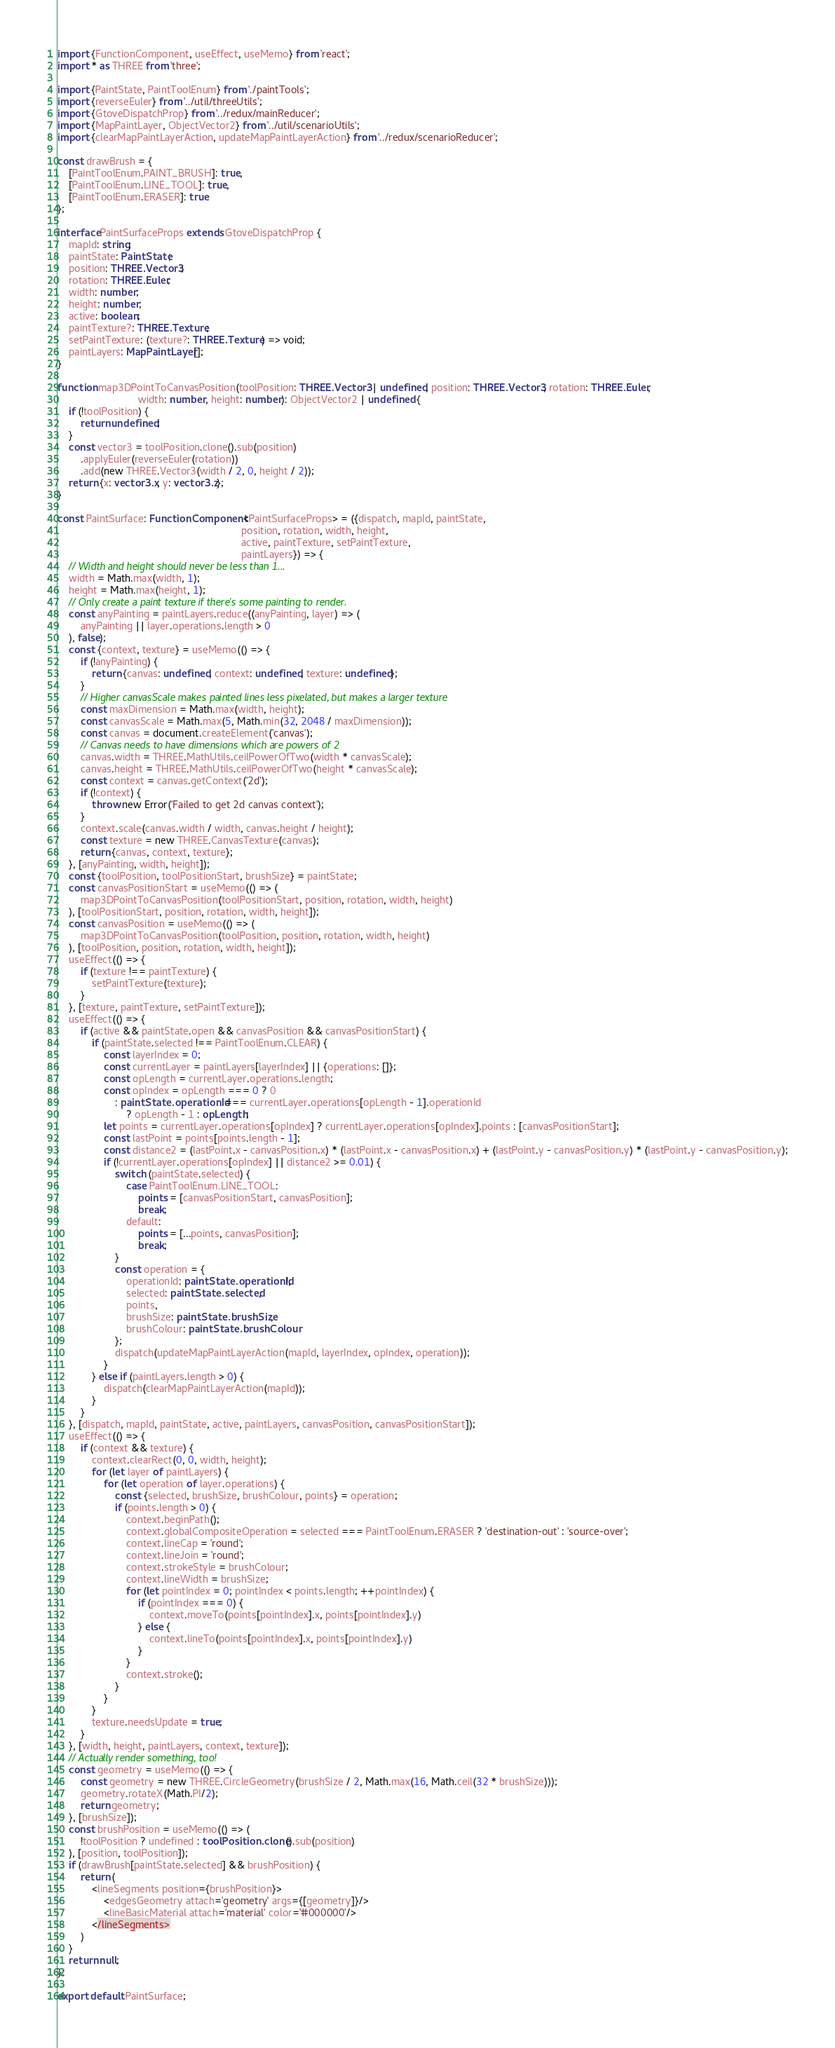Convert code to text. <code><loc_0><loc_0><loc_500><loc_500><_TypeScript_>import {FunctionComponent, useEffect, useMemo} from 'react';
import * as THREE from 'three';

import {PaintState, PaintToolEnum} from './paintTools';
import {reverseEuler} from '../util/threeUtils';
import {GtoveDispatchProp} from '../redux/mainReducer';
import {MapPaintLayer, ObjectVector2} from '../util/scenarioUtils';
import {clearMapPaintLayerAction, updateMapPaintLayerAction} from '../redux/scenarioReducer';

const drawBrush = {
    [PaintToolEnum.PAINT_BRUSH]: true,
    [PaintToolEnum.LINE_TOOL]: true,
    [PaintToolEnum.ERASER]: true
};

interface PaintSurfaceProps extends GtoveDispatchProp {
    mapId: string;
    paintState: PaintState;
    position: THREE.Vector3;
    rotation: THREE.Euler;
    width: number;
    height: number;
    active: boolean;
    paintTexture?: THREE.Texture;
    setPaintTexture: (texture?: THREE.Texture) => void;
    paintLayers: MapPaintLayer[];
}

function map3DPointToCanvasPosition(toolPosition: THREE.Vector3 | undefined, position: THREE.Vector3, rotation: THREE.Euler,
                            width: number, height: number): ObjectVector2 | undefined {
    if (!toolPosition) {
        return undefined;
    }
    const vector3 = toolPosition.clone().sub(position)
        .applyEuler(reverseEuler(rotation))
        .add(new THREE.Vector3(width / 2, 0, height / 2));
    return {x: vector3.x, y: vector3.z};
}

const PaintSurface: FunctionComponent<PaintSurfaceProps> = ({dispatch, mapId, paintState,
                                                                position, rotation, width, height,
                                                                active, paintTexture, setPaintTexture,
                                                                paintLayers}) => {
    // Width and height should never be less than 1...
    width = Math.max(width, 1);
    height = Math.max(height, 1);
    // Only create a paint texture if there's some painting to render.
    const anyPainting = paintLayers.reduce((anyPainting, layer) => (
        anyPainting || layer.operations.length > 0
    ), false);
    const {context, texture} = useMemo(() => {
        if (!anyPainting) {
            return {canvas: undefined, context: undefined, texture: undefined};
        }
        // Higher canvasScale makes painted lines less pixelated, but makes a larger texture
        const maxDimension = Math.max(width, height);
        const canvasScale = Math.max(5, Math.min(32, 2048 / maxDimension));
        const canvas = document.createElement('canvas');
        // Canvas needs to have dimensions which are powers of 2
        canvas.width = THREE.MathUtils.ceilPowerOfTwo(width * canvasScale);
        canvas.height = THREE.MathUtils.ceilPowerOfTwo(height * canvasScale);
        const context = canvas.getContext('2d');
        if (!context) {
            throw new Error('Failed to get 2d canvas context');
        }
        context.scale(canvas.width / width, canvas.height / height);
        const texture = new THREE.CanvasTexture(canvas);
        return {canvas, context, texture};
    }, [anyPainting, width, height]);
    const {toolPosition, toolPositionStart, brushSize} = paintState;
    const canvasPositionStart = useMemo(() => (
        map3DPointToCanvasPosition(toolPositionStart, position, rotation, width, height)
    ), [toolPositionStart, position, rotation, width, height]);
    const canvasPosition = useMemo(() => (
        map3DPointToCanvasPosition(toolPosition, position, rotation, width, height)
    ), [toolPosition, position, rotation, width, height]);
    useEffect(() => {
        if (texture !== paintTexture) {
            setPaintTexture(texture);
        }
    }, [texture, paintTexture, setPaintTexture]);
    useEffect(() => {
        if (active && paintState.open && canvasPosition && canvasPositionStart) {
            if (paintState.selected !== PaintToolEnum.CLEAR) {
                const layerIndex = 0;
                const currentLayer = paintLayers[layerIndex] || {operations: []};
                const opLength = currentLayer.operations.length;
                const opIndex = opLength === 0 ? 0
                    : paintState.operationId === currentLayer.operations[opLength - 1].operationId
                        ? opLength - 1 : opLength;
                let points = currentLayer.operations[opIndex] ? currentLayer.operations[opIndex].points : [canvasPositionStart];
                const lastPoint = points[points.length - 1];
                const distance2 = (lastPoint.x - canvasPosition.x) * (lastPoint.x - canvasPosition.x) + (lastPoint.y - canvasPosition.y) * (lastPoint.y - canvasPosition.y);
                if (!currentLayer.operations[opIndex] || distance2 >= 0.01) {
                    switch (paintState.selected) {
                        case PaintToolEnum.LINE_TOOL:
                            points = [canvasPositionStart, canvasPosition];
                            break;
                        default:
                            points = [...points, canvasPosition];
                            break;
                    }
                    const operation = {
                        operationId: paintState.operationId!,
                        selected: paintState.selected,
                        points,
                        brushSize: paintState.brushSize,
                        brushColour: paintState.brushColour
                    };
                    dispatch(updateMapPaintLayerAction(mapId, layerIndex, opIndex, operation));
                }
            } else if (paintLayers.length > 0) {
                dispatch(clearMapPaintLayerAction(mapId));
            }
        }
    }, [dispatch, mapId, paintState, active, paintLayers, canvasPosition, canvasPositionStart]);
    useEffect(() => {
        if (context && texture) {
            context.clearRect(0, 0, width, height);
            for (let layer of paintLayers) {
                for (let operation of layer.operations) {
                    const {selected, brushSize, brushColour, points} = operation;
                    if (points.length > 0) {
                        context.beginPath();
                        context.globalCompositeOperation = selected === PaintToolEnum.ERASER ? 'destination-out' : 'source-over';
                        context.lineCap = 'round';
                        context.lineJoin = 'round';
                        context.strokeStyle = brushColour;
                        context.lineWidth = brushSize;
                        for (let pointIndex = 0; pointIndex < points.length; ++pointIndex) {
                            if (pointIndex === 0) {
                                context.moveTo(points[pointIndex].x, points[pointIndex].y)
                            } else {
                                context.lineTo(points[pointIndex].x, points[pointIndex].y)
                            }
                        }
                        context.stroke();
                    }
                }
            }
            texture.needsUpdate = true;
        }
    }, [width, height, paintLayers, context, texture]);
    // Actually render something, too!
    const geometry = useMemo(() => {
        const geometry = new THREE.CircleGeometry(brushSize / 2, Math.max(16, Math.ceil(32 * brushSize)));
        geometry.rotateX(Math.PI/2);
        return geometry;
    }, [brushSize]);
    const brushPosition = useMemo(() => (
        !toolPosition ? undefined : toolPosition.clone().sub(position)
    ), [position, toolPosition]);
    if (drawBrush[paintState.selected] && brushPosition) {
        return (
            <lineSegments position={brushPosition}>
                <edgesGeometry attach='geometry' args={[geometry]}/>
                <lineBasicMaterial attach='material' color='#000000'/>
            </lineSegments>
        )
    }
    return null;
};

export default PaintSurface;</code> 